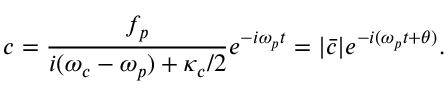<formula> <loc_0><loc_0><loc_500><loc_500>c = \frac { f _ { p } } { i ( \omega _ { c } - \omega _ { p } ) + \kappa _ { c } / 2 } e ^ { - i \omega _ { p } t } = | \bar { c } | e ^ { - i ( \omega _ { p } t + \theta ) } .</formula> 